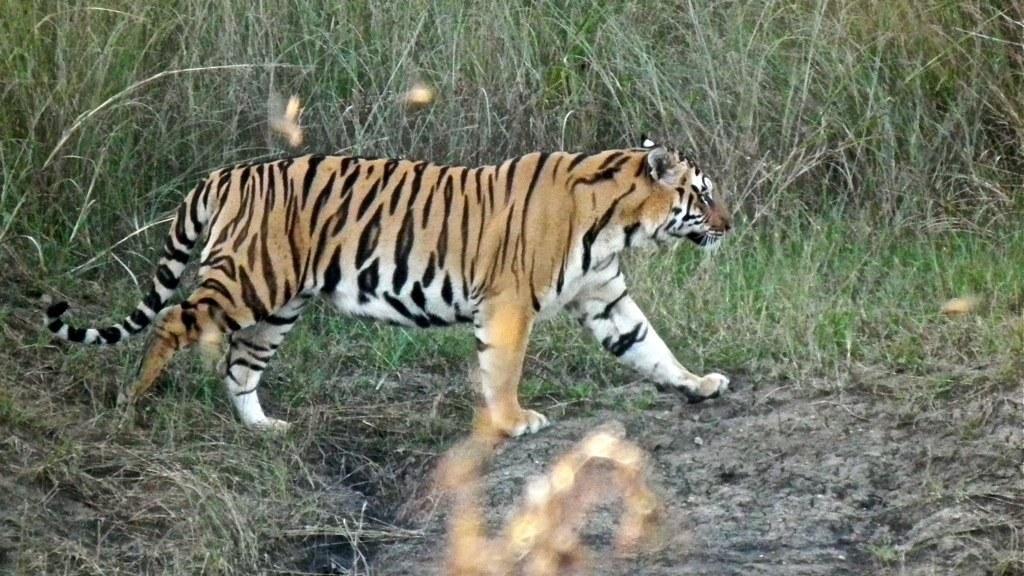Please provide a concise description of this image. In this picture there is a tiger walking. At the back there are plants. At the bottom there is mud and there is grass. 